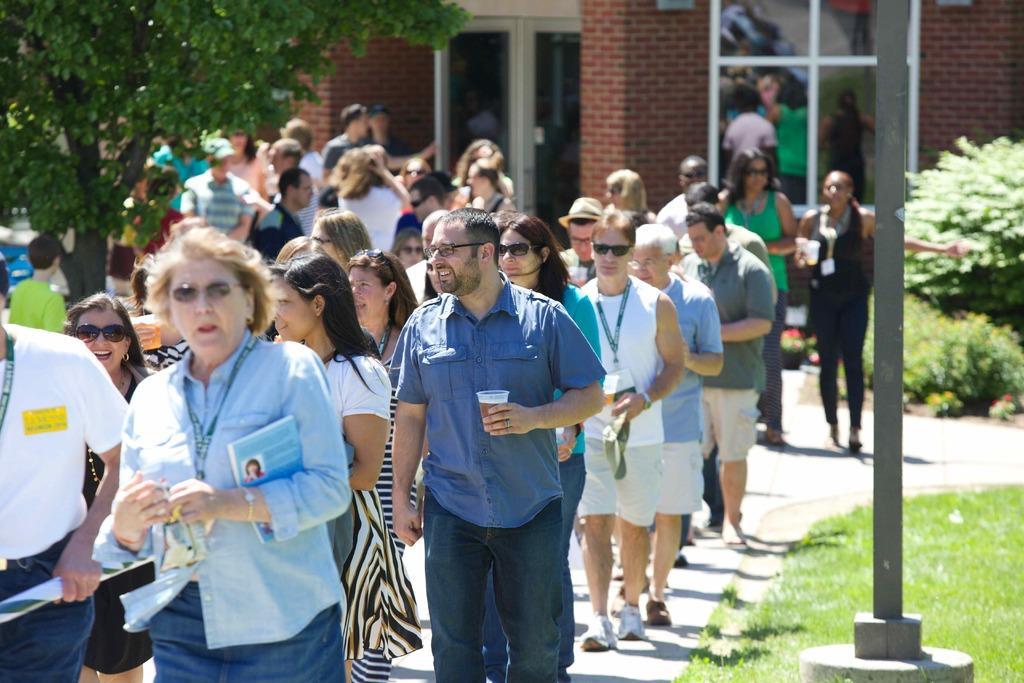How would you summarize this image in a sentence or two? In this image there are a group of people who are walking, in the background there is a building. On the right side there are some plants, grass and one pole. On the left side there is one tree. 